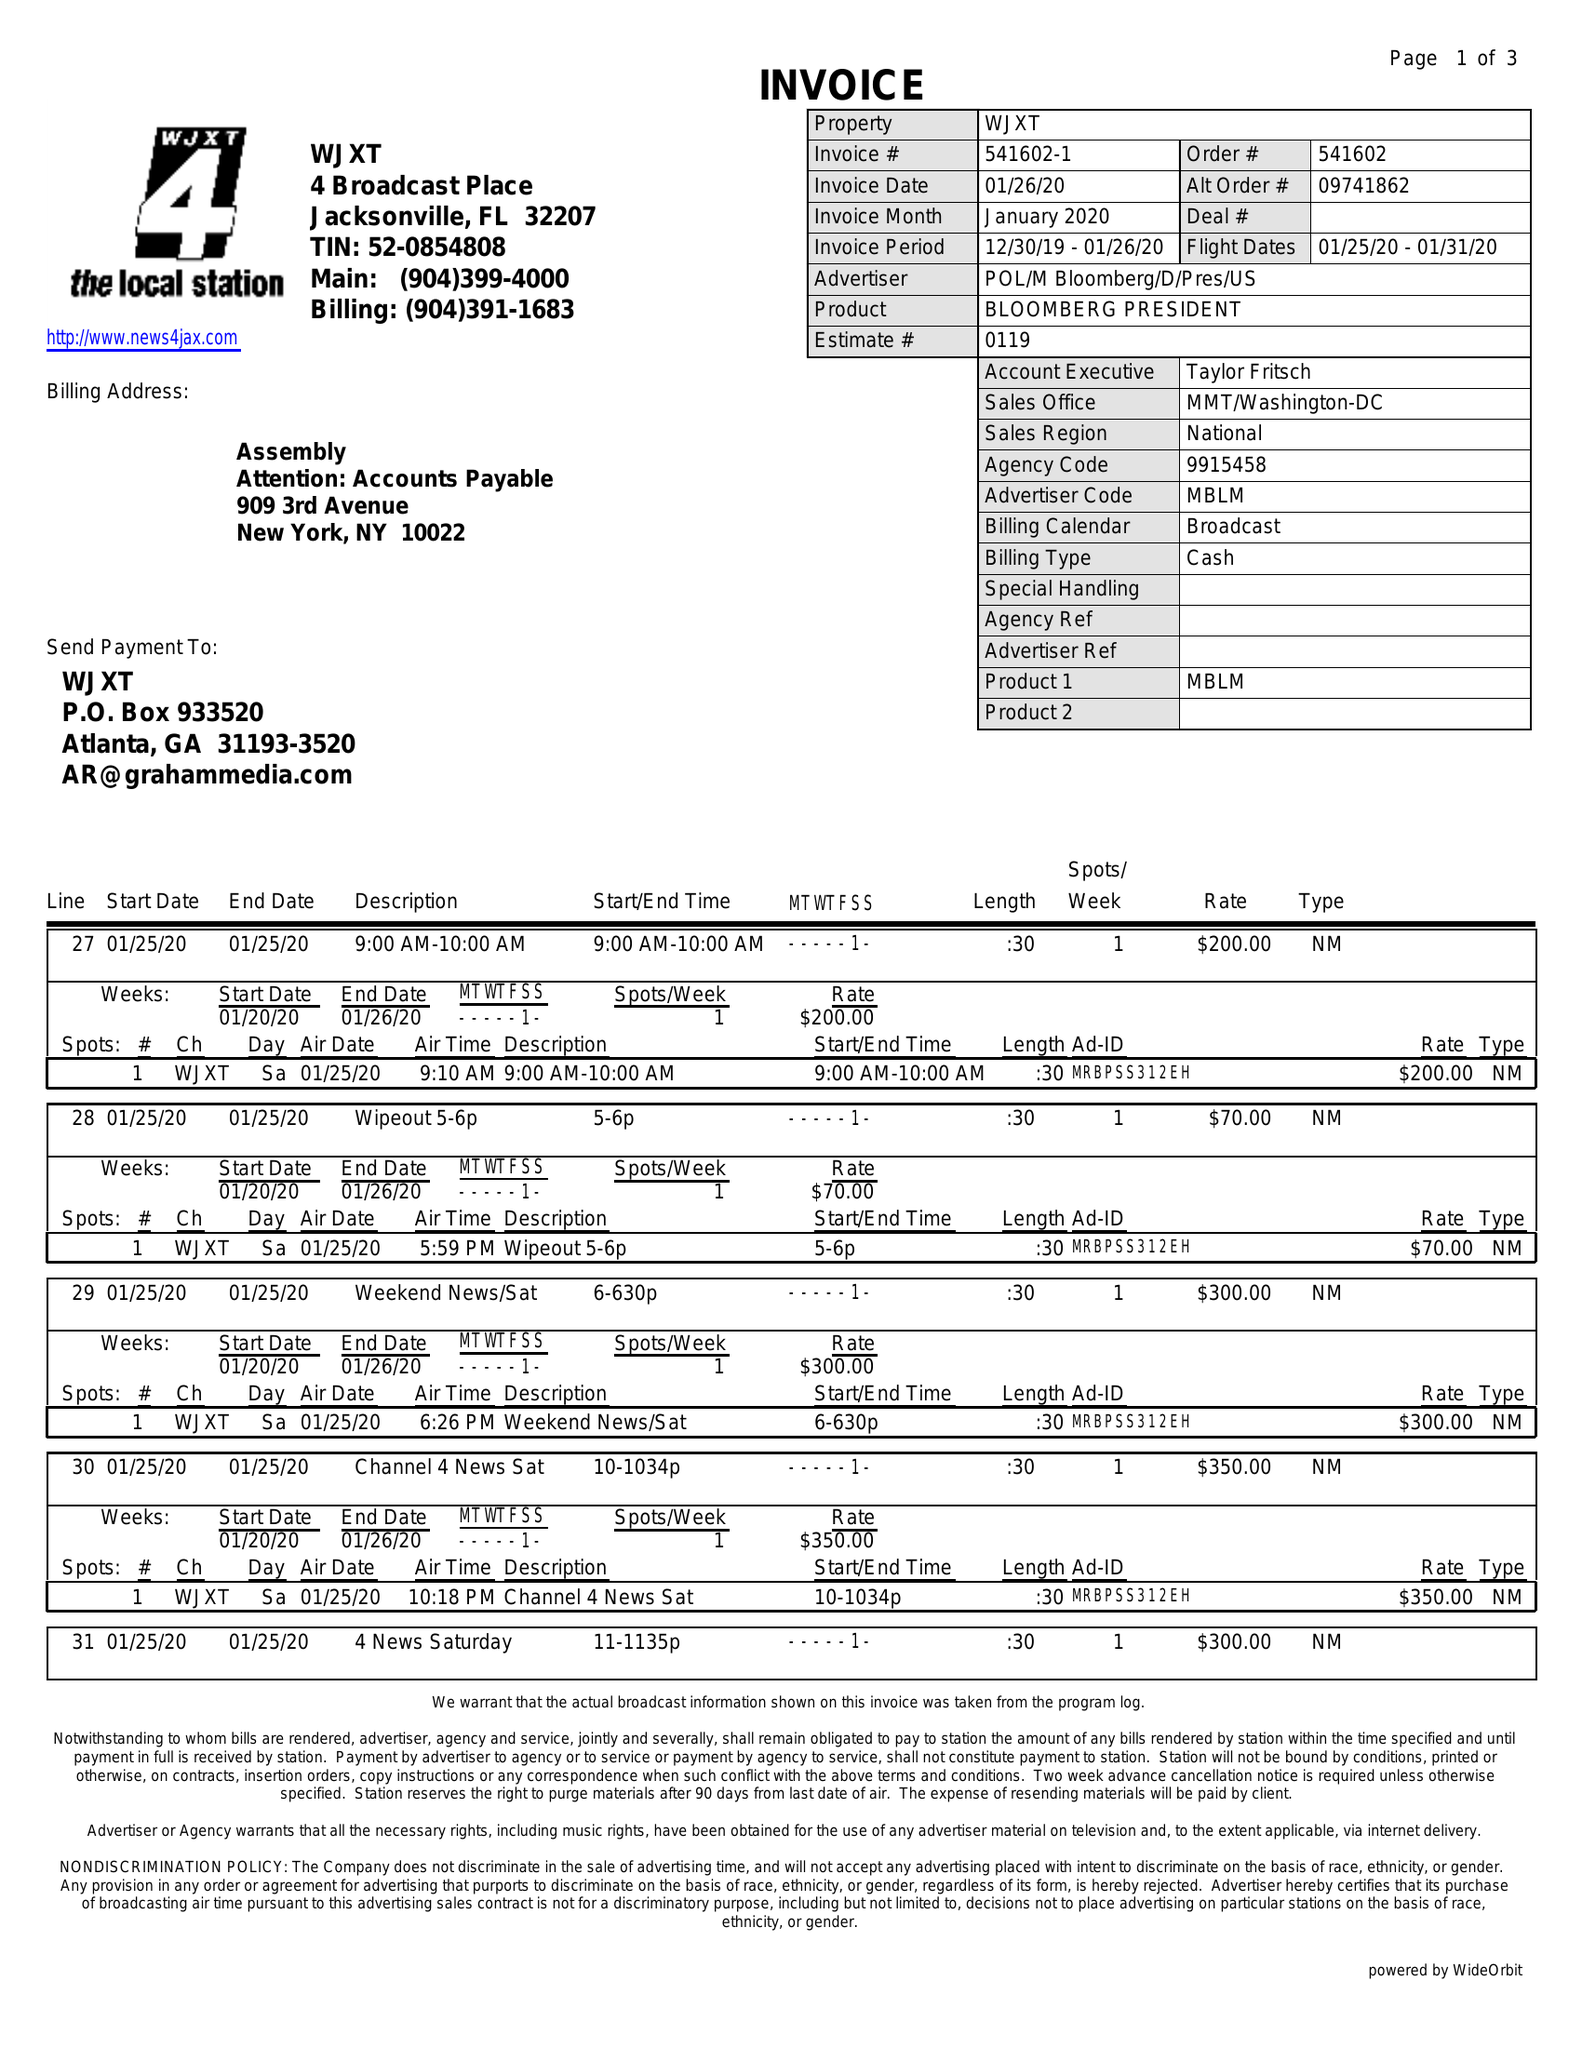What is the value for the advertiser?
Answer the question using a single word or phrase. POL/MBLOOMBERG/D/PRES/US 